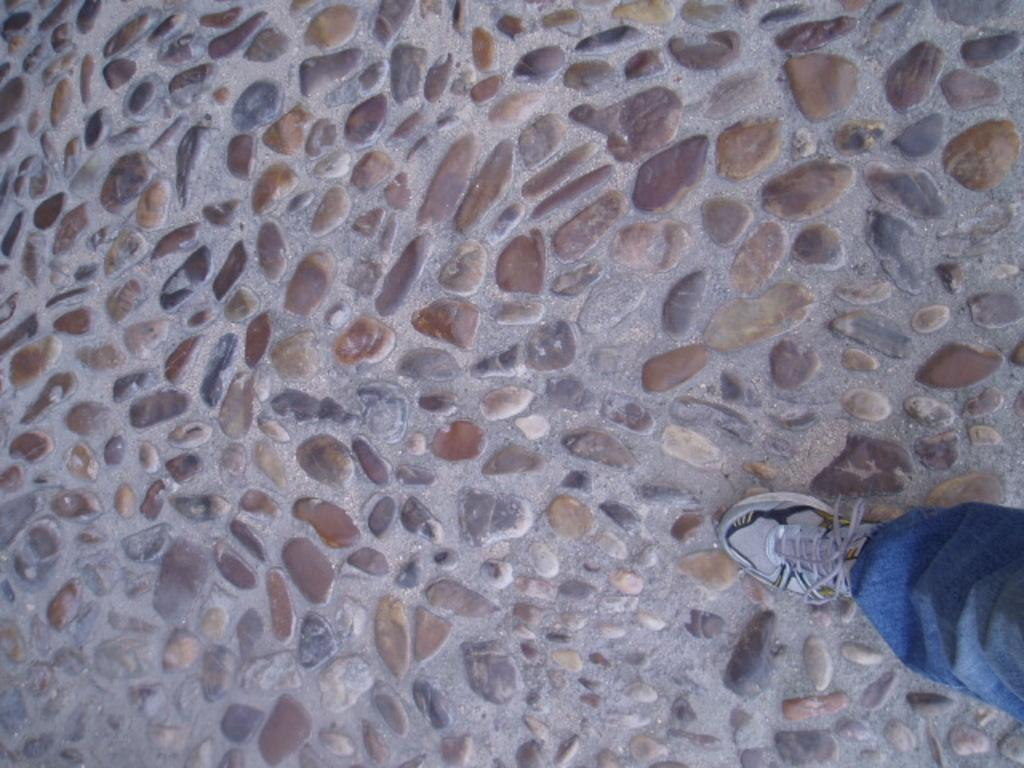What is located at the bottom of the image? There is a walkway at the bottom of the image. Can you describe the walkway? The walkway is a path that people can walk on. Is there anyone on the walkway? Yes, there is a person on the walkway. What type of thread is being used to sew the hen's feathers in the image? There is no hen or thread present in the image; it only features a walkway and a person. 